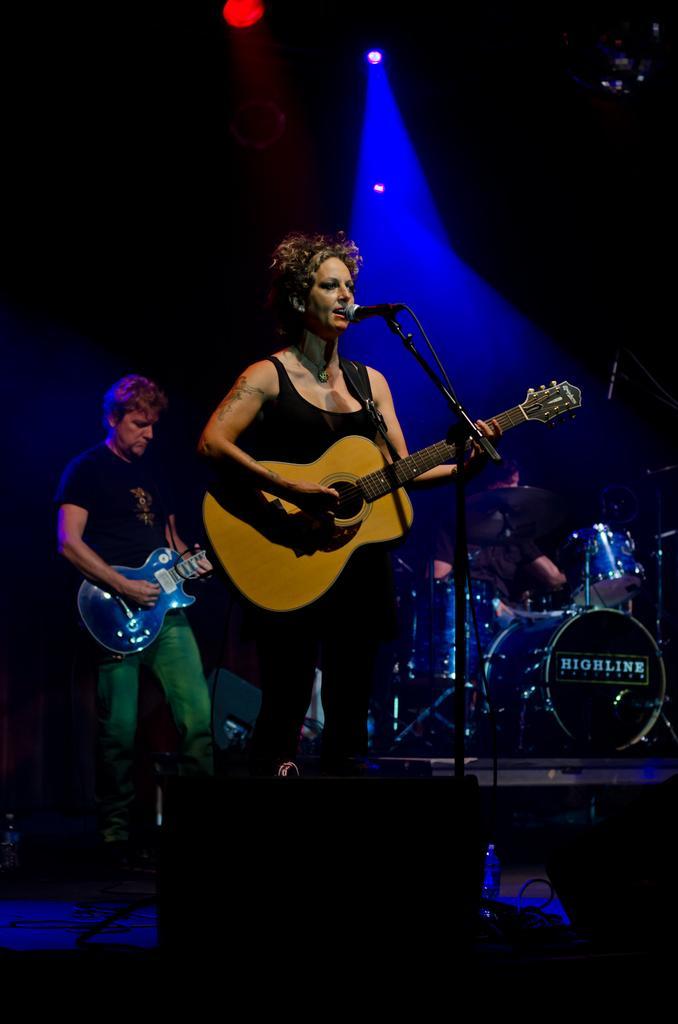In one or two sentences, can you explain what this image depicts? There is a woman standing at the center and she is holding a guitar in her hand. She is singing on a microphone. In the background there is a man standing on the left side and he is also holding a guitar in his hands. There is a drum arrangement on the right side. 